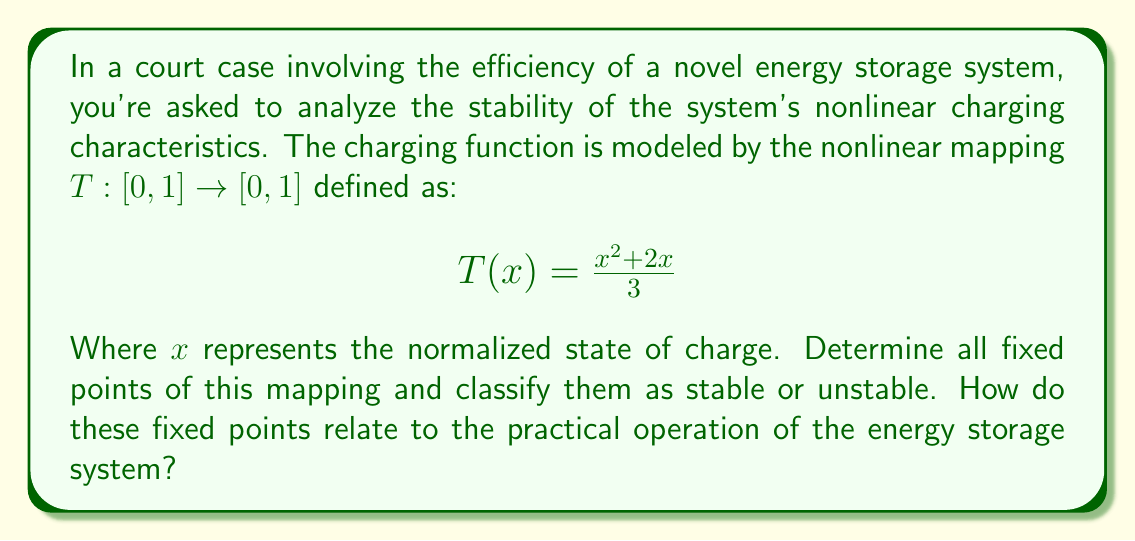Show me your answer to this math problem. To solve this problem, we need to follow these steps:

1) Find the fixed points:
   Fixed points occur when $T(x) = x$. So, we need to solve:
   $$\frac{x^2 + 2x}{3} = x$$

2) Simplify the equation:
   $$x^2 + 2x = 3x$$
   $$x^2 - x = 0$$
   $$x(x-1) = 0$$

3) Solve for x:
   The solutions are $x = 0$ and $x = 1$. These are our fixed points.

4) Classify the fixed points:
   To determine stability, we need to look at $|T'(x)|$ at each fixed point.
   $$T'(x) = \frac{2x + 2}{3}$$
   
   For $x = 0$:
   $|T'(0)| = |\frac{2}{3}| < 1$, so this is a stable fixed point.
   
   For $x = 1$:
   $|T'(1)| = |\frac{4}{3}| > 1$, so this is an unstable fixed point.

5) Interpretation for the energy storage system:
   - The stable fixed point at $x = 0$ represents a completely discharged state. The system will tend to stay in this state if it gets close to it.
   - The unstable fixed point at $x = 1$ represents a fully charged state. This state is unstable, meaning small perturbations will cause the system to move away from this state.
   - In practice, this means the system has a natural tendency to discharge, and maintaining a fully charged state may require active control or energy input.
Answer: The nonlinear mapping has two fixed points: $x = 0$ (stable) and $x = 1$ (unstable). The stable fixed point at $x = 0$ represents a completely discharged state, while the unstable fixed point at $x = 1$ represents a fully charged state. This indicates that the energy storage system has a natural tendency to discharge and may require active control to maintain a fully charged state. 